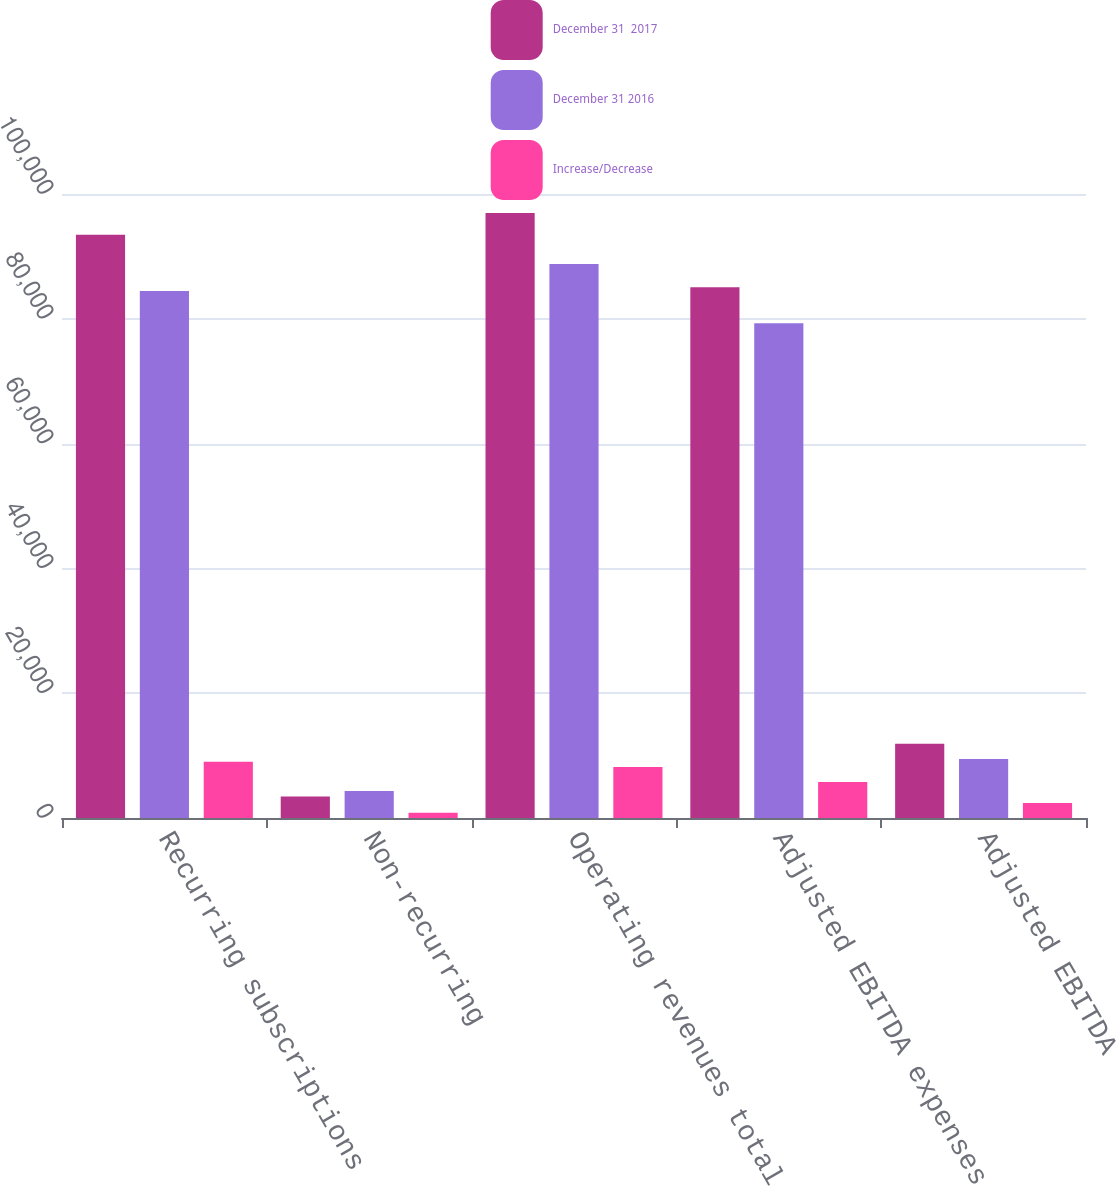Convert chart to OTSL. <chart><loc_0><loc_0><loc_500><loc_500><stacked_bar_chart><ecel><fcel>Recurring subscriptions<fcel>Non-recurring<fcel>Operating revenues total<fcel>Adjusted EBITDA expenses<fcel>Adjusted EBITDA<nl><fcel>December 31  2017<fcel>93481<fcel>3463<fcel>96944<fcel>85052<fcel>11892<nl><fcel>December 31 2016<fcel>84457<fcel>4308<fcel>88765<fcel>79293<fcel>9472<nl><fcel>Increase/Decrease<fcel>9024<fcel>845<fcel>8179<fcel>5759<fcel>2420<nl></chart> 